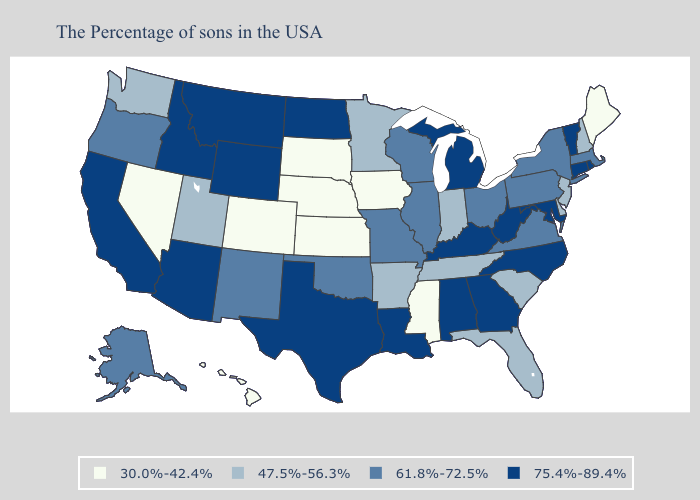Does Delaware have the lowest value in the South?
Keep it brief. No. Name the states that have a value in the range 61.8%-72.5%?
Give a very brief answer. Massachusetts, New York, Pennsylvania, Virginia, Ohio, Wisconsin, Illinois, Missouri, Oklahoma, New Mexico, Oregon, Alaska. Name the states that have a value in the range 47.5%-56.3%?
Quick response, please. New Hampshire, New Jersey, Delaware, South Carolina, Florida, Indiana, Tennessee, Arkansas, Minnesota, Utah, Washington. Is the legend a continuous bar?
Answer briefly. No. Among the states that border Arizona , does Utah have the highest value?
Quick response, please. No. Name the states that have a value in the range 75.4%-89.4%?
Concise answer only. Rhode Island, Vermont, Connecticut, Maryland, North Carolina, West Virginia, Georgia, Michigan, Kentucky, Alabama, Louisiana, Texas, North Dakota, Wyoming, Montana, Arizona, Idaho, California. What is the lowest value in the South?
Quick response, please. 30.0%-42.4%. Name the states that have a value in the range 61.8%-72.5%?
Concise answer only. Massachusetts, New York, Pennsylvania, Virginia, Ohio, Wisconsin, Illinois, Missouri, Oklahoma, New Mexico, Oregon, Alaska. What is the value of Maryland?
Short answer required. 75.4%-89.4%. What is the value of Georgia?
Give a very brief answer. 75.4%-89.4%. Does Oklahoma have a higher value than Utah?
Short answer required. Yes. Does New Mexico have a higher value than Colorado?
Answer briefly. Yes. Which states hav the highest value in the West?
Answer briefly. Wyoming, Montana, Arizona, Idaho, California. Does Oklahoma have a lower value than Rhode Island?
Short answer required. Yes. What is the value of Wisconsin?
Concise answer only. 61.8%-72.5%. 